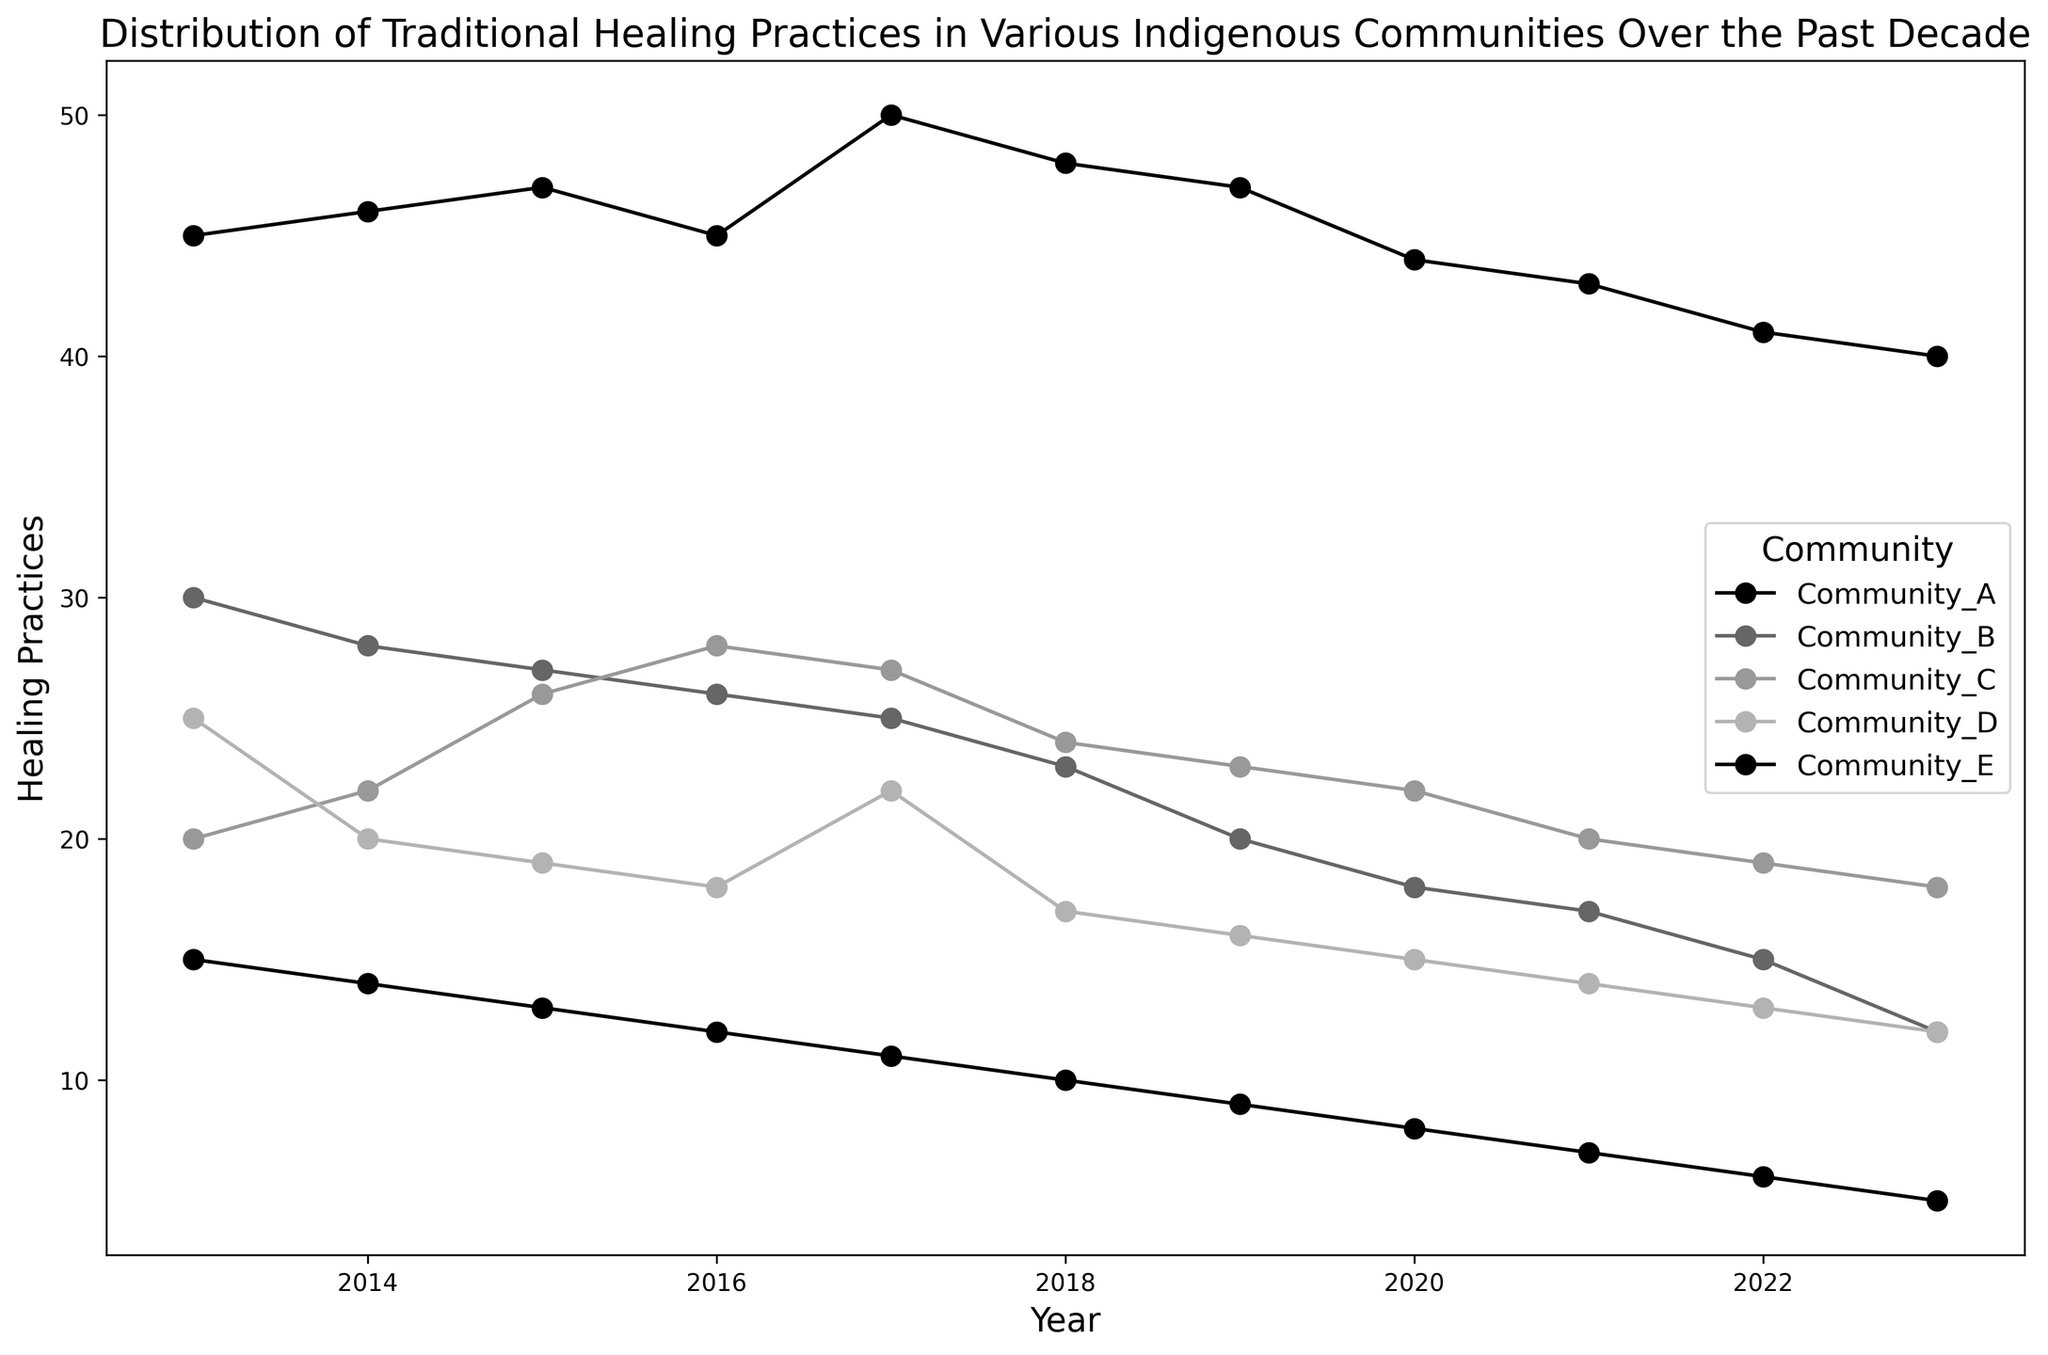What is the general trend in the number of healing practices in Community A over the past decade? Observing the plotted line for Community A, we notice it begins at 45 in 2013 and gradually decreases to 40 by 2023, indicating a general decline over the decade.
Answer: Declining Which community had the highest number of healing practices in 2023? Looking at the endpoints of the plot lines for 2023, Community A ends at 40, which is the highest value among the communities for that year.
Answer: Community A Between which years did Community D show the steepest decline in the number of healing practices? By examining the segments of Community D’s line, the steepest slope appears between 2014 and 2015, where the value drops from 20 to 19.
Answer: 2014 to 2015 What is the average number of healing practices in Community E from 2013 to 2023? Summing up the values for Community E (15 + 14 + 13 + 12 + 11 + 10 + 9 + 8 + 7 + 6 + 5) results in 110, and dividing by 11 years gives an average of 10.
Answer: 10 Which community has shown the most consistent decrease in healing practices over the years? Community E’s line shows a consistent downward trend from 15 in 2013 to 5 in 2023 without any fluctuations, indicating it is the most consistent.
Answer: Community E In what year did Community B experience the largest drop in its number of healing practices? The largest drop for Community B can be observed between 2019 and 2020 where it falls sharply from 20 to 18.
Answer: 2019 to 2020 How many communities had their healing practices decline by more than 30% from 2013 to 2023? Examining each community’s 2013 and 2023 values, Community B (30 to 12), Community D (25 to 12), and Community E (15 to 5) saw declines greater than 30%.
Answer: 3 Compare the number of healing practices in Community C in 2015 and 2023. Is it higher, lower, or the same? In 2015, Community C had 26 healing practices and in 2023 it had 18. This shows a decrease.
Answer: Lower What is the total number of healing practices in all communities combined in the year 2015? Adding values from 2015 for all communities (47 + 27 + 26 + 19 + 13) results in a total of 132 healing practices.
Answer: 132 